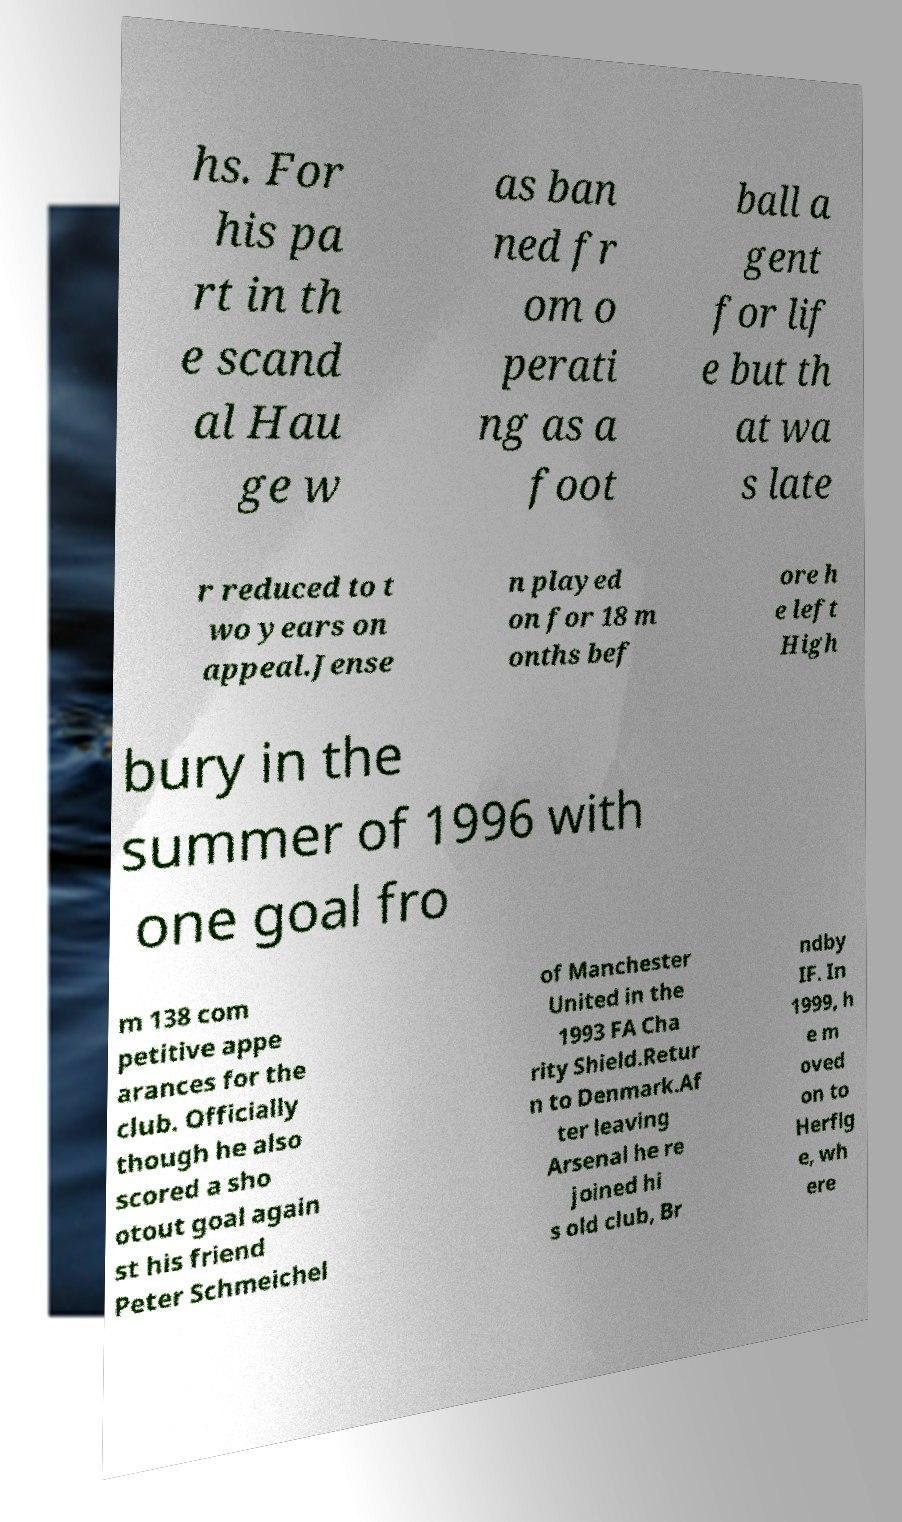Can you read and provide the text displayed in the image? This photo seems to have some interesting text. Can you extract and type it out for me? Certainly! Here is the text extracted from the image: 'hs. For his part in the scandal, Hauge was banned from operating as a football agent for life, but that was later reduced to two years on appeal. Jensen played on for 18 months before he left Highbury in the summer of 1996 with one goal from 138 competitive appearances for the club. Officially, though he also scored a shootout goal against his friend Peter Schmeichel of Manchester United in the 1993 FA Charity Shield. Return to Denmark. After leaving Arsenal, he rejoined his old club, Brøndby IF. In 1999, he moved on to Herfølge, where.' 